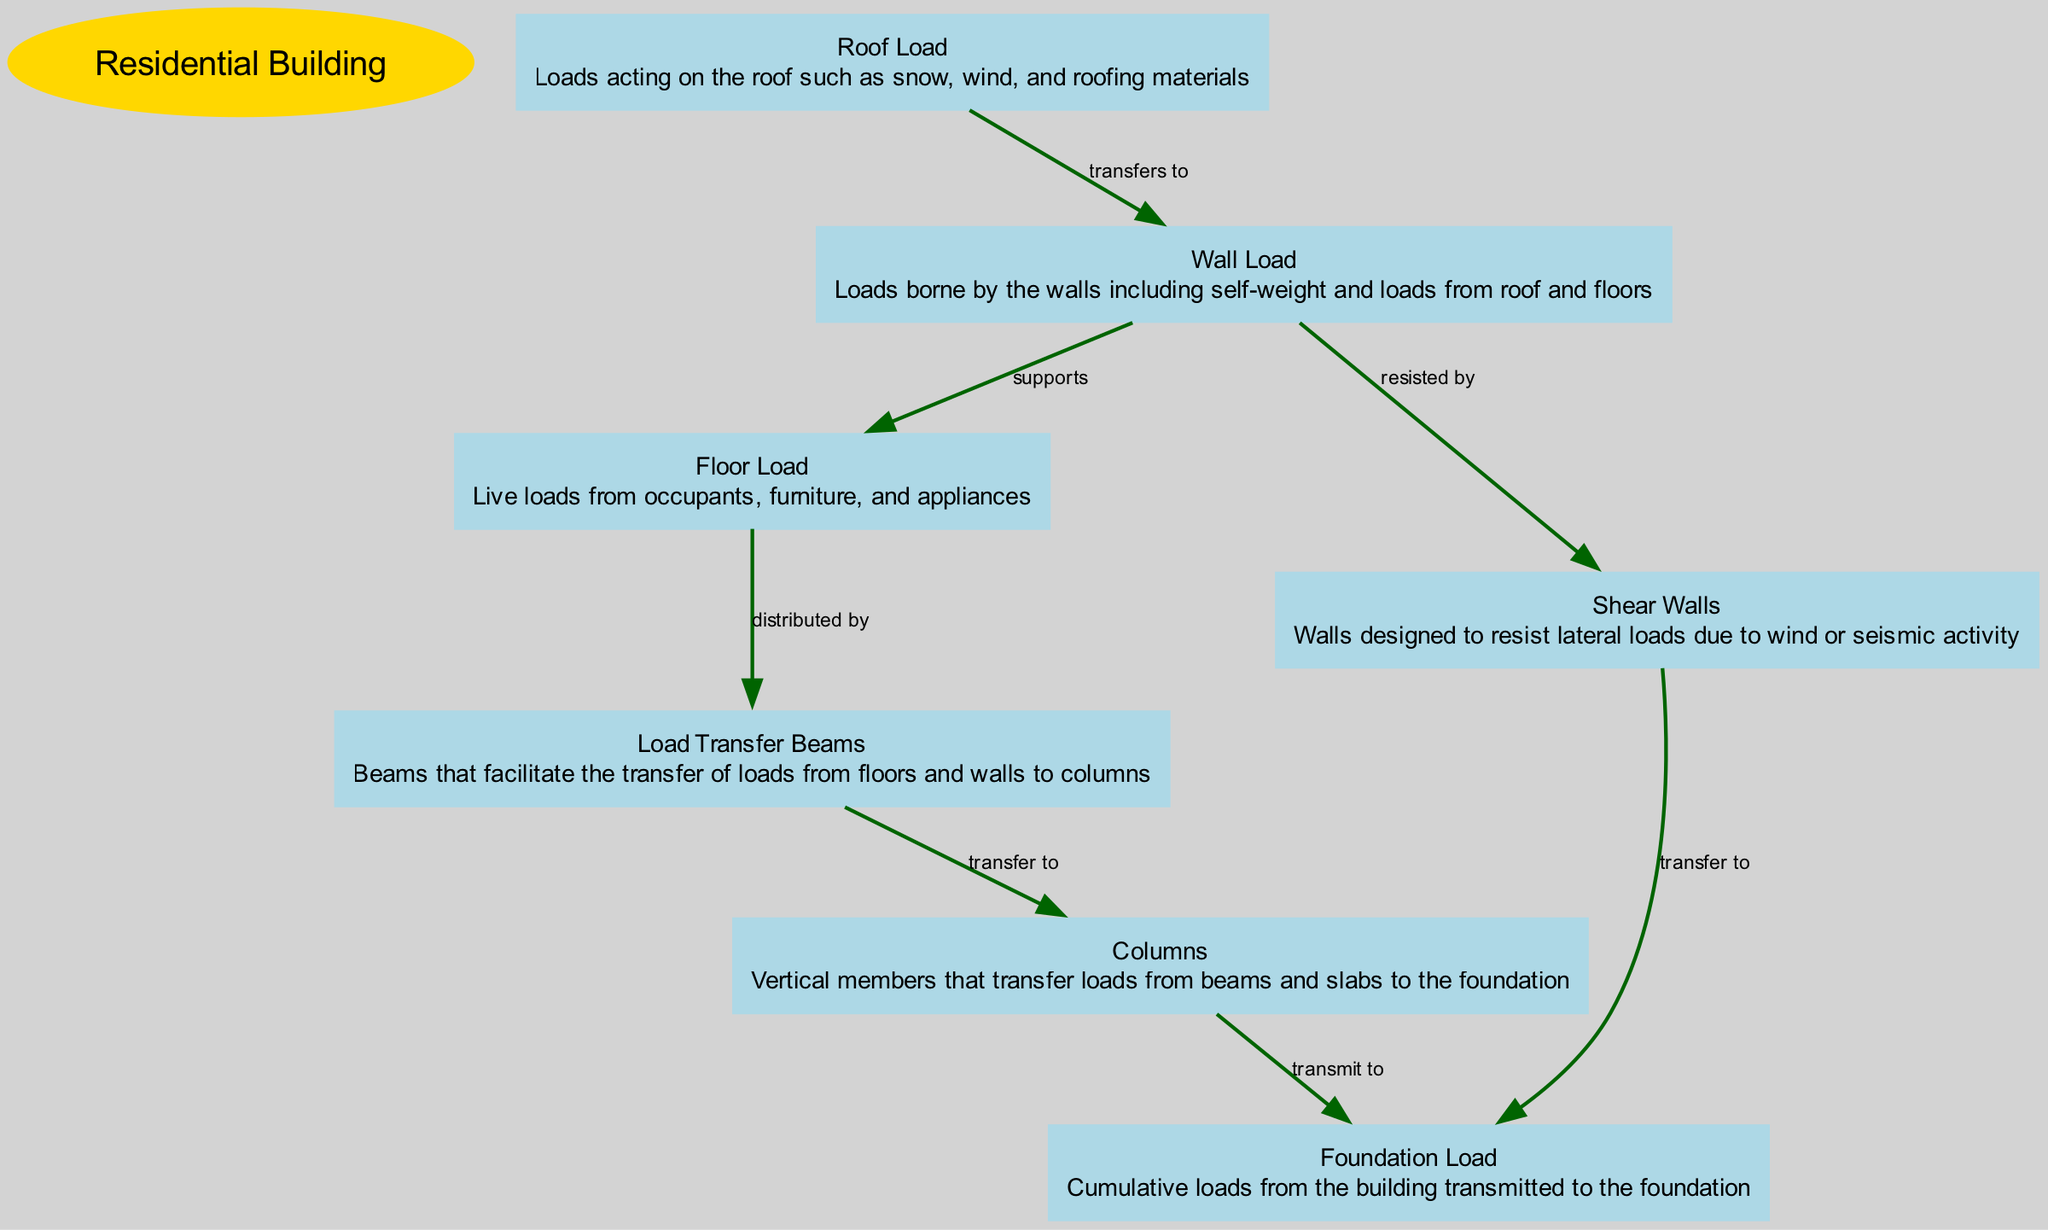What is the main structural element analyzed in the diagram? The main element is indicated by the "main" type in the diagram which specifies the entire structure being analyzed. The title of the diagram "Structural Load Distribution Analysis in a Residential Building" directly mentions the residential building as the focus.
Answer: Residential Building How many nodes are present in the diagram? To find the number of nodes, count all elements classified as "node" in the data provided. The nodes include Roof Load, Wall Load, Floor Load, Foundation Load, Load Transfer Beams, Columns, and Shear Walls, giving a total of 7 nodes.
Answer: 7 What does the Roof Load transfer to? By examining the edges in the diagram, it shows a direct edge indicating that the Roof Load transfers to the Wall Load. The connection is explicitly stated as "transfers to".
Answer: Wall Load Which component supports the Floor Load? The diagram outlines a clear relationship where the Wall Load supports the Floor Load, as indicated by the edge labeled "supports". This shows the dependency of the Floor Load on the Wall Load.
Answer: Wall Load What is the cumulative load transferred to from Columns? The diagram indicates that Columns transmit the load to the Foundation Load, noting this relationship is shown through the labeled edge "transmit to". This suggests Columns play a crucial role in load distribution to the foundation.
Answer: Foundation Load What load do Shear Walls resist? The Shear Walls are indicated to resist the Wall Load as shown by the edge stating "resisted by". This reflects their function in maintaining the structural integrity against lateral loads.
Answer: Wall Load What facilitates the transfer of loads from floors and walls to Columns? The Load Transfer Beams are specifically designated in the diagram as the component that facilitates the transfer of loads from both floors and walls to the Columns as indicated by the edge "transfer to".
Answer: Load Transfer Beams Through which nodes does the Wall Load distribute its support? The Wall Load provides support both to the Floor Load and also transfers load to the Shear Walls, evidenced by the edges "supports" and "resisted by" respectively, indicating a dual function in the load distribution process.
Answer: Floor Load, Shear Walls 